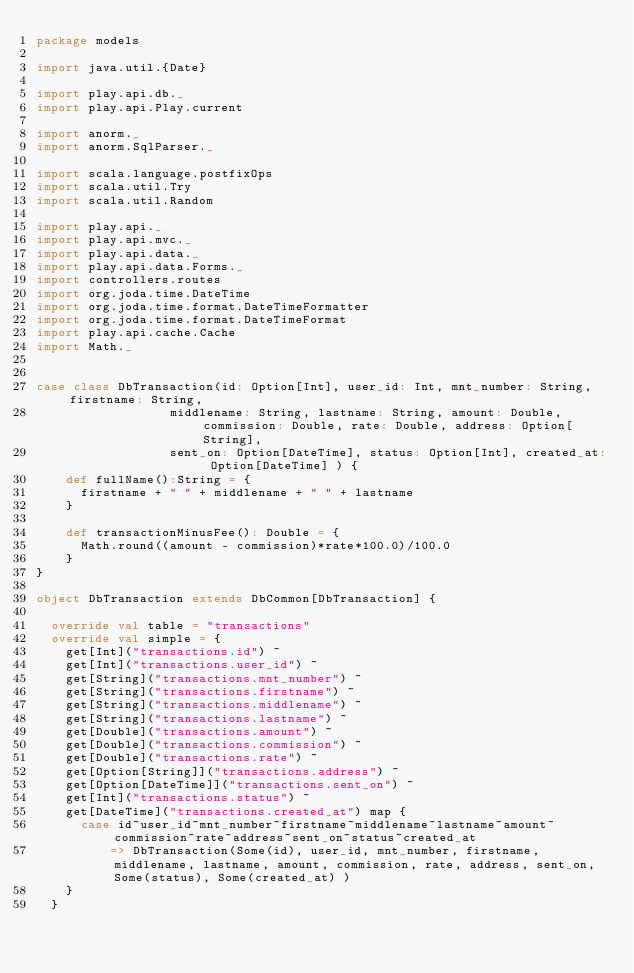<code> <loc_0><loc_0><loc_500><loc_500><_Scala_>package models

import java.util.{Date}

import play.api.db._
import play.api.Play.current

import anorm._
import anorm.SqlParser._

import scala.language.postfixOps
import scala.util.Try
import scala.util.Random

import play.api._
import play.api.mvc._
import play.api.data._
import play.api.data.Forms._
import controllers.routes
import org.joda.time.DateTime
import org.joda.time.format.DateTimeFormatter
import org.joda.time.format.DateTimeFormat
import play.api.cache.Cache
import Math._


case class DbTransaction(id: Option[Int], user_id: Int, mnt_number: String, firstname: String, 
                  middlename: String, lastname: String, amount: Double, commission: Double, rate: Double, address: Option[String],
                  sent_on: Option[DateTime], status: Option[Int], created_at: Option[DateTime] ) {
    def fullName():String = {
      firstname + " " + middlename + " " + lastname
    }
    
    def transactionMinusFee(): Double = {
      Math.round((amount - commission)*rate*100.0)/100.0
    }
}

object DbTransaction extends DbCommon[DbTransaction] {
  
  override val table = "transactions"
  override val simple = {
    get[Int]("transactions.id") ~
    get[Int]("transactions.user_id") ~
    get[String]("transactions.mnt_number") ~
    get[String]("transactions.firstname") ~
    get[String]("transactions.middlename") ~
    get[String]("transactions.lastname") ~
    get[Double]("transactions.amount") ~
    get[Double]("transactions.commission") ~
    get[Double]("transactions.rate") ~
    get[Option[String]]("transactions.address") ~
    get[Option[DateTime]]("transactions.sent_on") ~
    get[Int]("transactions.status") ~
    get[DateTime]("transactions.created_at") map {
      case id~user_id~mnt_number~firstname~middlename~lastname~amount~commission~rate~address~sent_on~status~created_at 
          => DbTransaction(Some(id), user_id, mnt_number, firstname, middlename, lastname, amount, commission, rate, address, sent_on, Some(status), Some(created_at) )
    }
  }    
  </code> 